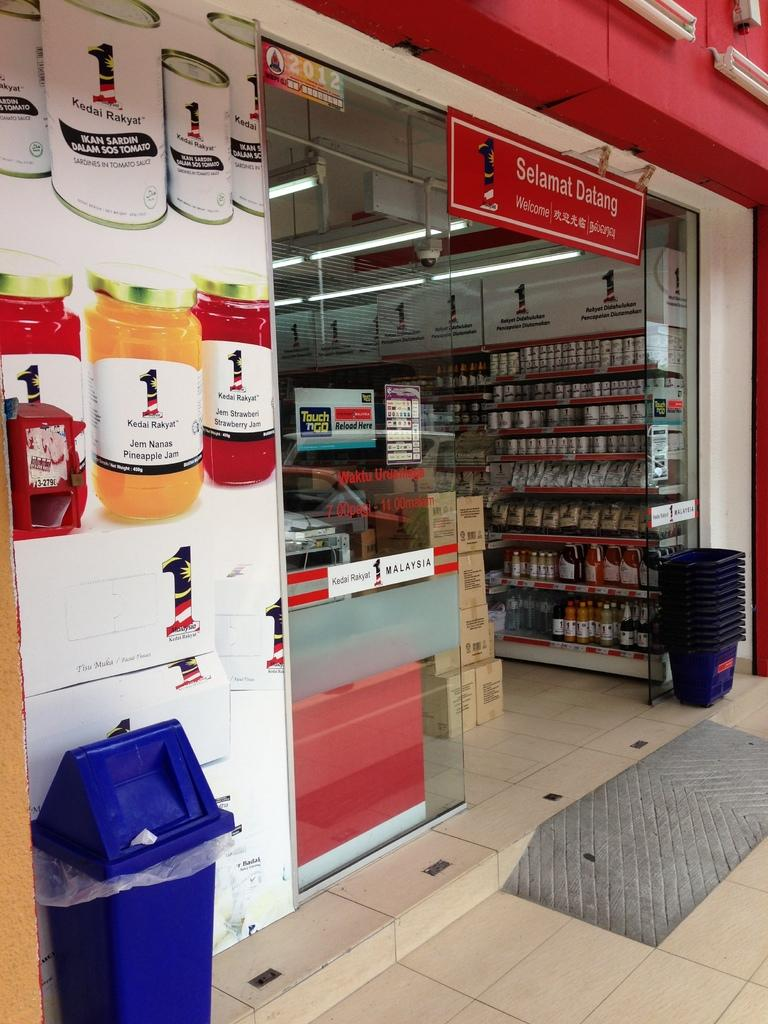<image>
Create a compact narrative representing the image presented. a yellow jar with Kedai written on it 